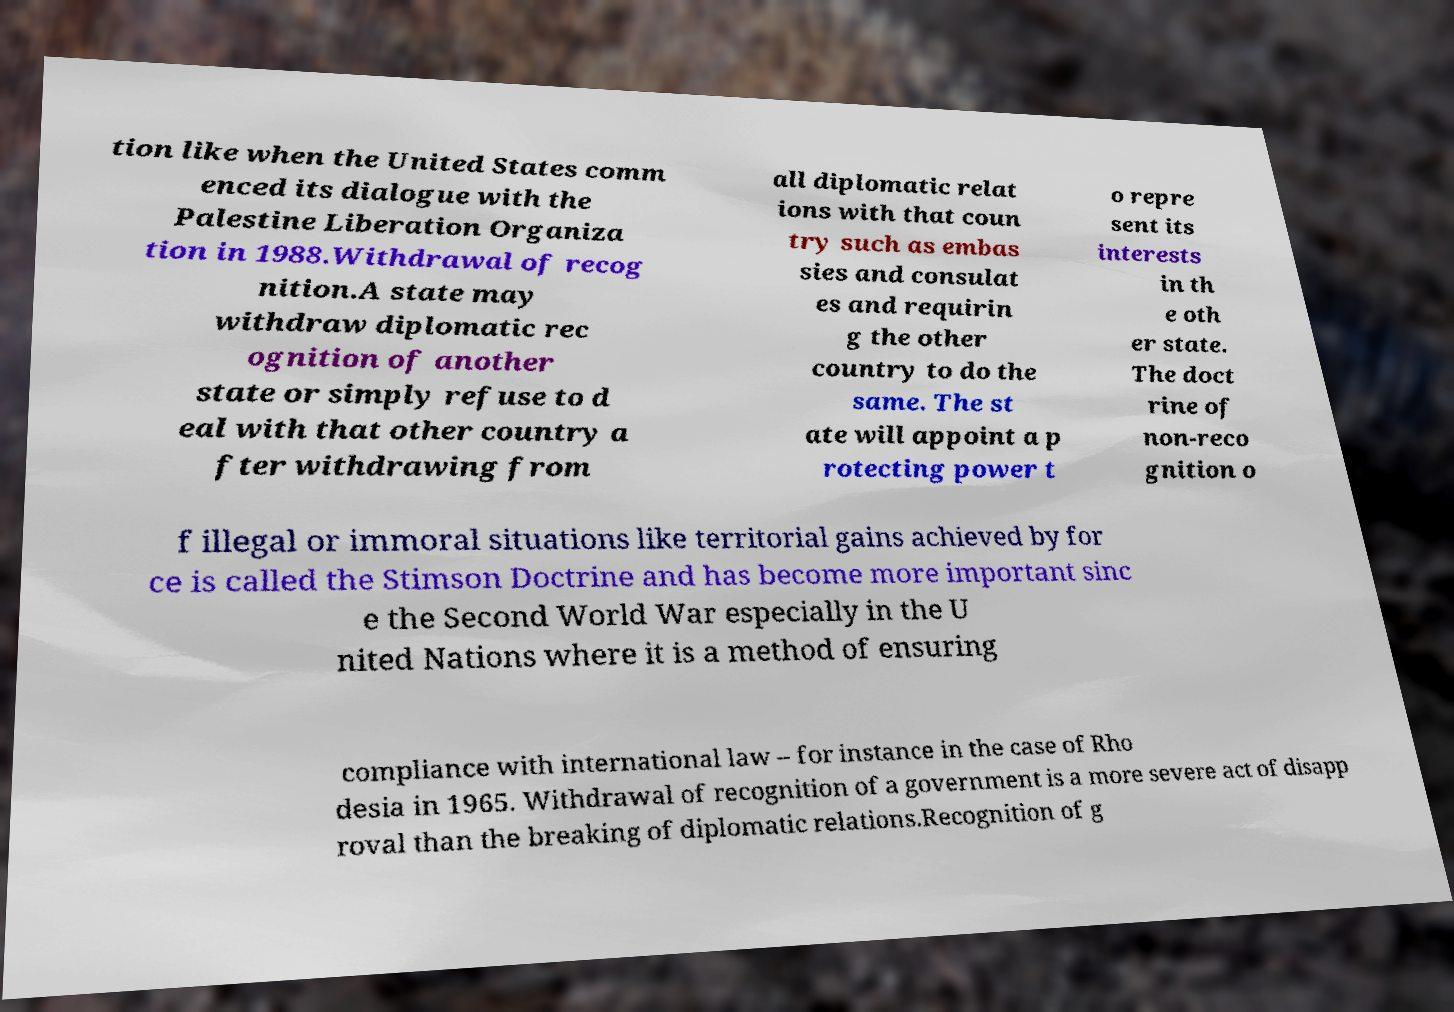What messages or text are displayed in this image? I need them in a readable, typed format. tion like when the United States comm enced its dialogue with the Palestine Liberation Organiza tion in 1988.Withdrawal of recog nition.A state may withdraw diplomatic rec ognition of another state or simply refuse to d eal with that other country a fter withdrawing from all diplomatic relat ions with that coun try such as embas sies and consulat es and requirin g the other country to do the same. The st ate will appoint a p rotecting power t o repre sent its interests in th e oth er state. The doct rine of non-reco gnition o f illegal or immoral situations like territorial gains achieved by for ce is called the Stimson Doctrine and has become more important sinc e the Second World War especially in the U nited Nations where it is a method of ensuring compliance with international law – for instance in the case of Rho desia in 1965. Withdrawal of recognition of a government is a more severe act of disapp roval than the breaking of diplomatic relations.Recognition of g 